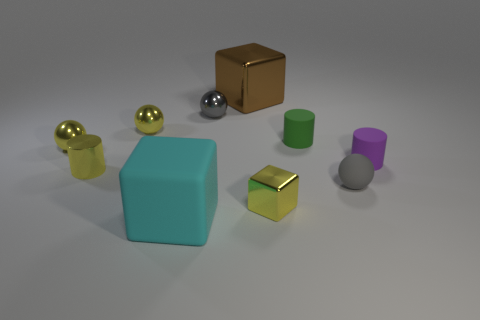How many small metallic spheres have the same color as the rubber ball?
Make the answer very short. 1. There is a cylinder on the left side of the yellow shiny block; is there a tiny shiny sphere that is left of it?
Your answer should be very brief. Yes. Does the big block that is behind the gray metal thing have the same color as the cylinder that is left of the big cyan object?
Offer a very short reply. No. There is another cube that is the same size as the brown block; what is its color?
Give a very brief answer. Cyan. Are there an equal number of brown metal cubes that are on the right side of the small purple object and tiny spheres that are right of the large rubber cube?
Provide a succinct answer. No. There is a block that is behind the small rubber cylinder behind the purple matte cylinder; what is it made of?
Offer a very short reply. Metal. What number of things are brown metal cylinders or rubber cylinders?
Your answer should be very brief. 2. Is the number of small gray rubber balls less than the number of big metallic spheres?
Provide a succinct answer. No. There is a cyan cube that is the same material as the green thing; what size is it?
Offer a very short reply. Large. The brown cube has what size?
Keep it short and to the point. Large. 